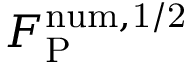<formula> <loc_0><loc_0><loc_500><loc_500>F _ { P } ^ { n u m , 1 / 2 }</formula> 